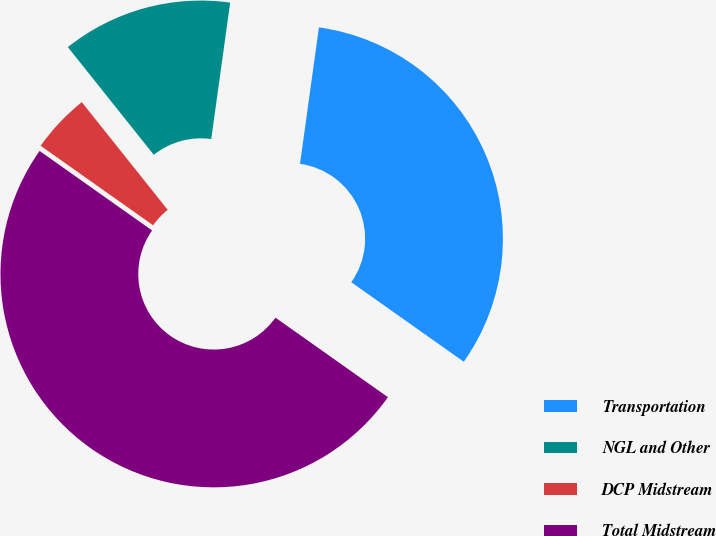Convert chart to OTSL. <chart><loc_0><loc_0><loc_500><loc_500><pie_chart><fcel>Transportation<fcel>NGL and Other<fcel>DCP Midstream<fcel>Total Midstream<nl><fcel>32.6%<fcel>12.91%<fcel>4.49%<fcel>50.0%<nl></chart> 